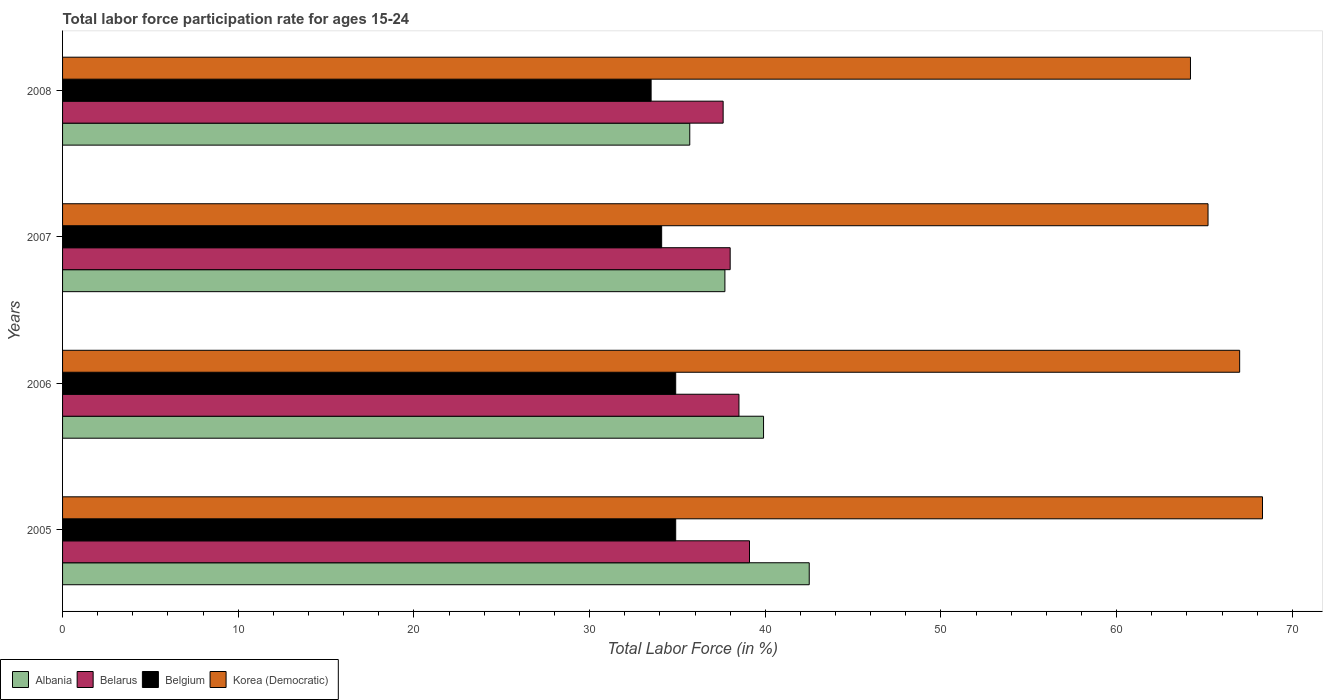How many different coloured bars are there?
Offer a very short reply. 4. Are the number of bars per tick equal to the number of legend labels?
Your answer should be compact. Yes. How many bars are there on the 2nd tick from the top?
Provide a succinct answer. 4. What is the label of the 2nd group of bars from the top?
Your answer should be very brief. 2007. What is the labor force participation rate in Belgium in 2007?
Your answer should be very brief. 34.1. Across all years, what is the maximum labor force participation rate in Albania?
Offer a terse response. 42.5. Across all years, what is the minimum labor force participation rate in Belarus?
Provide a succinct answer. 37.6. What is the total labor force participation rate in Korea (Democratic) in the graph?
Provide a succinct answer. 264.7. What is the difference between the labor force participation rate in Korea (Democratic) in 2006 and that in 2008?
Your answer should be compact. 2.8. What is the difference between the labor force participation rate in Belarus in 2006 and the labor force participation rate in Belgium in 2007?
Offer a terse response. 4.4. What is the average labor force participation rate in Korea (Democratic) per year?
Your answer should be compact. 66.17. In the year 2005, what is the difference between the labor force participation rate in Korea (Democratic) and labor force participation rate in Albania?
Keep it short and to the point. 25.8. In how many years, is the labor force participation rate in Korea (Democratic) greater than 56 %?
Your answer should be very brief. 4. What is the ratio of the labor force participation rate in Albania in 2007 to that in 2008?
Give a very brief answer. 1.06. Is the labor force participation rate in Korea (Democratic) in 2005 less than that in 2008?
Provide a succinct answer. No. Is the difference between the labor force participation rate in Korea (Democratic) in 2006 and 2008 greater than the difference between the labor force participation rate in Albania in 2006 and 2008?
Give a very brief answer. No. What is the difference between the highest and the second highest labor force participation rate in Korea (Democratic)?
Keep it short and to the point. 1.3. What is the difference between the highest and the lowest labor force participation rate in Albania?
Provide a short and direct response. 6.8. What does the 3rd bar from the top in 2006 represents?
Provide a short and direct response. Belarus. What does the 1st bar from the bottom in 2005 represents?
Your answer should be compact. Albania. How many bars are there?
Make the answer very short. 16. Are all the bars in the graph horizontal?
Your response must be concise. Yes. Are the values on the major ticks of X-axis written in scientific E-notation?
Offer a terse response. No. Does the graph contain grids?
Provide a succinct answer. No. Where does the legend appear in the graph?
Provide a succinct answer. Bottom left. How are the legend labels stacked?
Offer a very short reply. Horizontal. What is the title of the graph?
Provide a succinct answer. Total labor force participation rate for ages 15-24. What is the label or title of the X-axis?
Offer a terse response. Total Labor Force (in %). What is the label or title of the Y-axis?
Make the answer very short. Years. What is the Total Labor Force (in %) of Albania in 2005?
Your answer should be compact. 42.5. What is the Total Labor Force (in %) in Belarus in 2005?
Provide a short and direct response. 39.1. What is the Total Labor Force (in %) in Belgium in 2005?
Offer a very short reply. 34.9. What is the Total Labor Force (in %) of Korea (Democratic) in 2005?
Your response must be concise. 68.3. What is the Total Labor Force (in %) in Albania in 2006?
Ensure brevity in your answer.  39.9. What is the Total Labor Force (in %) in Belarus in 2006?
Your response must be concise. 38.5. What is the Total Labor Force (in %) of Belgium in 2006?
Give a very brief answer. 34.9. What is the Total Labor Force (in %) of Albania in 2007?
Make the answer very short. 37.7. What is the Total Labor Force (in %) in Belgium in 2007?
Give a very brief answer. 34.1. What is the Total Labor Force (in %) of Korea (Democratic) in 2007?
Offer a terse response. 65.2. What is the Total Labor Force (in %) in Albania in 2008?
Your response must be concise. 35.7. What is the Total Labor Force (in %) of Belarus in 2008?
Make the answer very short. 37.6. What is the Total Labor Force (in %) in Belgium in 2008?
Ensure brevity in your answer.  33.5. What is the Total Labor Force (in %) of Korea (Democratic) in 2008?
Provide a succinct answer. 64.2. Across all years, what is the maximum Total Labor Force (in %) of Albania?
Your answer should be very brief. 42.5. Across all years, what is the maximum Total Labor Force (in %) in Belarus?
Your response must be concise. 39.1. Across all years, what is the maximum Total Labor Force (in %) in Belgium?
Give a very brief answer. 34.9. Across all years, what is the maximum Total Labor Force (in %) of Korea (Democratic)?
Your answer should be very brief. 68.3. Across all years, what is the minimum Total Labor Force (in %) of Albania?
Offer a terse response. 35.7. Across all years, what is the minimum Total Labor Force (in %) of Belarus?
Your response must be concise. 37.6. Across all years, what is the minimum Total Labor Force (in %) of Belgium?
Give a very brief answer. 33.5. Across all years, what is the minimum Total Labor Force (in %) of Korea (Democratic)?
Ensure brevity in your answer.  64.2. What is the total Total Labor Force (in %) in Albania in the graph?
Your response must be concise. 155.8. What is the total Total Labor Force (in %) in Belarus in the graph?
Provide a short and direct response. 153.2. What is the total Total Labor Force (in %) of Belgium in the graph?
Your answer should be very brief. 137.4. What is the total Total Labor Force (in %) of Korea (Democratic) in the graph?
Make the answer very short. 264.7. What is the difference between the Total Labor Force (in %) in Albania in 2005 and that in 2006?
Provide a short and direct response. 2.6. What is the difference between the Total Labor Force (in %) of Belarus in 2005 and that in 2006?
Keep it short and to the point. 0.6. What is the difference between the Total Labor Force (in %) of Belgium in 2005 and that in 2006?
Provide a succinct answer. 0. What is the difference between the Total Labor Force (in %) of Korea (Democratic) in 2005 and that in 2006?
Keep it short and to the point. 1.3. What is the difference between the Total Labor Force (in %) in Albania in 2005 and that in 2007?
Make the answer very short. 4.8. What is the difference between the Total Labor Force (in %) of Belgium in 2005 and that in 2007?
Ensure brevity in your answer.  0.8. What is the difference between the Total Labor Force (in %) in Korea (Democratic) in 2005 and that in 2007?
Keep it short and to the point. 3.1. What is the difference between the Total Labor Force (in %) in Albania in 2005 and that in 2008?
Make the answer very short. 6.8. What is the difference between the Total Labor Force (in %) in Belgium in 2005 and that in 2008?
Offer a terse response. 1.4. What is the difference between the Total Labor Force (in %) in Albania in 2006 and that in 2007?
Keep it short and to the point. 2.2. What is the difference between the Total Labor Force (in %) in Belarus in 2006 and that in 2007?
Provide a succinct answer. 0.5. What is the difference between the Total Labor Force (in %) in Albania in 2006 and that in 2008?
Keep it short and to the point. 4.2. What is the difference between the Total Labor Force (in %) of Belarus in 2006 and that in 2008?
Make the answer very short. 0.9. What is the difference between the Total Labor Force (in %) in Belgium in 2006 and that in 2008?
Make the answer very short. 1.4. What is the difference between the Total Labor Force (in %) of Korea (Democratic) in 2006 and that in 2008?
Offer a very short reply. 2.8. What is the difference between the Total Labor Force (in %) of Albania in 2007 and that in 2008?
Offer a very short reply. 2. What is the difference between the Total Labor Force (in %) of Belarus in 2007 and that in 2008?
Make the answer very short. 0.4. What is the difference between the Total Labor Force (in %) in Albania in 2005 and the Total Labor Force (in %) in Korea (Democratic) in 2006?
Keep it short and to the point. -24.5. What is the difference between the Total Labor Force (in %) in Belarus in 2005 and the Total Labor Force (in %) in Belgium in 2006?
Your answer should be very brief. 4.2. What is the difference between the Total Labor Force (in %) in Belarus in 2005 and the Total Labor Force (in %) in Korea (Democratic) in 2006?
Offer a very short reply. -27.9. What is the difference between the Total Labor Force (in %) of Belgium in 2005 and the Total Labor Force (in %) of Korea (Democratic) in 2006?
Your answer should be very brief. -32.1. What is the difference between the Total Labor Force (in %) in Albania in 2005 and the Total Labor Force (in %) in Belarus in 2007?
Your answer should be very brief. 4.5. What is the difference between the Total Labor Force (in %) of Albania in 2005 and the Total Labor Force (in %) of Belgium in 2007?
Give a very brief answer. 8.4. What is the difference between the Total Labor Force (in %) in Albania in 2005 and the Total Labor Force (in %) in Korea (Democratic) in 2007?
Provide a short and direct response. -22.7. What is the difference between the Total Labor Force (in %) in Belarus in 2005 and the Total Labor Force (in %) in Korea (Democratic) in 2007?
Provide a succinct answer. -26.1. What is the difference between the Total Labor Force (in %) in Belgium in 2005 and the Total Labor Force (in %) in Korea (Democratic) in 2007?
Your answer should be compact. -30.3. What is the difference between the Total Labor Force (in %) of Albania in 2005 and the Total Labor Force (in %) of Korea (Democratic) in 2008?
Your answer should be compact. -21.7. What is the difference between the Total Labor Force (in %) in Belarus in 2005 and the Total Labor Force (in %) in Belgium in 2008?
Your response must be concise. 5.6. What is the difference between the Total Labor Force (in %) in Belarus in 2005 and the Total Labor Force (in %) in Korea (Democratic) in 2008?
Your answer should be compact. -25.1. What is the difference between the Total Labor Force (in %) in Belgium in 2005 and the Total Labor Force (in %) in Korea (Democratic) in 2008?
Keep it short and to the point. -29.3. What is the difference between the Total Labor Force (in %) in Albania in 2006 and the Total Labor Force (in %) in Korea (Democratic) in 2007?
Offer a very short reply. -25.3. What is the difference between the Total Labor Force (in %) of Belarus in 2006 and the Total Labor Force (in %) of Belgium in 2007?
Provide a succinct answer. 4.4. What is the difference between the Total Labor Force (in %) in Belarus in 2006 and the Total Labor Force (in %) in Korea (Democratic) in 2007?
Your answer should be very brief. -26.7. What is the difference between the Total Labor Force (in %) of Belgium in 2006 and the Total Labor Force (in %) of Korea (Democratic) in 2007?
Keep it short and to the point. -30.3. What is the difference between the Total Labor Force (in %) in Albania in 2006 and the Total Labor Force (in %) in Korea (Democratic) in 2008?
Provide a short and direct response. -24.3. What is the difference between the Total Labor Force (in %) of Belarus in 2006 and the Total Labor Force (in %) of Belgium in 2008?
Offer a very short reply. 5. What is the difference between the Total Labor Force (in %) in Belarus in 2006 and the Total Labor Force (in %) in Korea (Democratic) in 2008?
Provide a succinct answer. -25.7. What is the difference between the Total Labor Force (in %) in Belgium in 2006 and the Total Labor Force (in %) in Korea (Democratic) in 2008?
Make the answer very short. -29.3. What is the difference between the Total Labor Force (in %) of Albania in 2007 and the Total Labor Force (in %) of Belarus in 2008?
Your answer should be very brief. 0.1. What is the difference between the Total Labor Force (in %) in Albania in 2007 and the Total Labor Force (in %) in Belgium in 2008?
Give a very brief answer. 4.2. What is the difference between the Total Labor Force (in %) of Albania in 2007 and the Total Labor Force (in %) of Korea (Democratic) in 2008?
Make the answer very short. -26.5. What is the difference between the Total Labor Force (in %) of Belarus in 2007 and the Total Labor Force (in %) of Belgium in 2008?
Provide a succinct answer. 4.5. What is the difference between the Total Labor Force (in %) in Belarus in 2007 and the Total Labor Force (in %) in Korea (Democratic) in 2008?
Offer a very short reply. -26.2. What is the difference between the Total Labor Force (in %) in Belgium in 2007 and the Total Labor Force (in %) in Korea (Democratic) in 2008?
Provide a succinct answer. -30.1. What is the average Total Labor Force (in %) of Albania per year?
Your answer should be compact. 38.95. What is the average Total Labor Force (in %) of Belarus per year?
Ensure brevity in your answer.  38.3. What is the average Total Labor Force (in %) of Belgium per year?
Your answer should be compact. 34.35. What is the average Total Labor Force (in %) of Korea (Democratic) per year?
Your answer should be compact. 66.17. In the year 2005, what is the difference between the Total Labor Force (in %) of Albania and Total Labor Force (in %) of Belarus?
Make the answer very short. 3.4. In the year 2005, what is the difference between the Total Labor Force (in %) in Albania and Total Labor Force (in %) in Belgium?
Your answer should be very brief. 7.6. In the year 2005, what is the difference between the Total Labor Force (in %) of Albania and Total Labor Force (in %) of Korea (Democratic)?
Offer a terse response. -25.8. In the year 2005, what is the difference between the Total Labor Force (in %) in Belarus and Total Labor Force (in %) in Belgium?
Offer a terse response. 4.2. In the year 2005, what is the difference between the Total Labor Force (in %) of Belarus and Total Labor Force (in %) of Korea (Democratic)?
Offer a terse response. -29.2. In the year 2005, what is the difference between the Total Labor Force (in %) of Belgium and Total Labor Force (in %) of Korea (Democratic)?
Offer a very short reply. -33.4. In the year 2006, what is the difference between the Total Labor Force (in %) in Albania and Total Labor Force (in %) in Belgium?
Make the answer very short. 5. In the year 2006, what is the difference between the Total Labor Force (in %) of Albania and Total Labor Force (in %) of Korea (Democratic)?
Provide a short and direct response. -27.1. In the year 2006, what is the difference between the Total Labor Force (in %) of Belarus and Total Labor Force (in %) of Korea (Democratic)?
Your answer should be compact. -28.5. In the year 2006, what is the difference between the Total Labor Force (in %) of Belgium and Total Labor Force (in %) of Korea (Democratic)?
Keep it short and to the point. -32.1. In the year 2007, what is the difference between the Total Labor Force (in %) in Albania and Total Labor Force (in %) in Belarus?
Provide a short and direct response. -0.3. In the year 2007, what is the difference between the Total Labor Force (in %) in Albania and Total Labor Force (in %) in Korea (Democratic)?
Offer a very short reply. -27.5. In the year 2007, what is the difference between the Total Labor Force (in %) in Belarus and Total Labor Force (in %) in Belgium?
Provide a succinct answer. 3.9. In the year 2007, what is the difference between the Total Labor Force (in %) in Belarus and Total Labor Force (in %) in Korea (Democratic)?
Your answer should be compact. -27.2. In the year 2007, what is the difference between the Total Labor Force (in %) in Belgium and Total Labor Force (in %) in Korea (Democratic)?
Your response must be concise. -31.1. In the year 2008, what is the difference between the Total Labor Force (in %) in Albania and Total Labor Force (in %) in Belarus?
Ensure brevity in your answer.  -1.9. In the year 2008, what is the difference between the Total Labor Force (in %) of Albania and Total Labor Force (in %) of Belgium?
Your answer should be very brief. 2.2. In the year 2008, what is the difference between the Total Labor Force (in %) in Albania and Total Labor Force (in %) in Korea (Democratic)?
Provide a succinct answer. -28.5. In the year 2008, what is the difference between the Total Labor Force (in %) in Belarus and Total Labor Force (in %) in Belgium?
Provide a short and direct response. 4.1. In the year 2008, what is the difference between the Total Labor Force (in %) of Belarus and Total Labor Force (in %) of Korea (Democratic)?
Ensure brevity in your answer.  -26.6. In the year 2008, what is the difference between the Total Labor Force (in %) in Belgium and Total Labor Force (in %) in Korea (Democratic)?
Offer a very short reply. -30.7. What is the ratio of the Total Labor Force (in %) in Albania in 2005 to that in 2006?
Provide a short and direct response. 1.07. What is the ratio of the Total Labor Force (in %) of Belarus in 2005 to that in 2006?
Keep it short and to the point. 1.02. What is the ratio of the Total Labor Force (in %) in Korea (Democratic) in 2005 to that in 2006?
Your answer should be compact. 1.02. What is the ratio of the Total Labor Force (in %) of Albania in 2005 to that in 2007?
Offer a terse response. 1.13. What is the ratio of the Total Labor Force (in %) of Belarus in 2005 to that in 2007?
Your answer should be very brief. 1.03. What is the ratio of the Total Labor Force (in %) of Belgium in 2005 to that in 2007?
Give a very brief answer. 1.02. What is the ratio of the Total Labor Force (in %) in Korea (Democratic) in 2005 to that in 2007?
Your answer should be very brief. 1.05. What is the ratio of the Total Labor Force (in %) of Albania in 2005 to that in 2008?
Offer a very short reply. 1.19. What is the ratio of the Total Labor Force (in %) of Belarus in 2005 to that in 2008?
Your answer should be compact. 1.04. What is the ratio of the Total Labor Force (in %) in Belgium in 2005 to that in 2008?
Give a very brief answer. 1.04. What is the ratio of the Total Labor Force (in %) in Korea (Democratic) in 2005 to that in 2008?
Offer a terse response. 1.06. What is the ratio of the Total Labor Force (in %) of Albania in 2006 to that in 2007?
Your answer should be compact. 1.06. What is the ratio of the Total Labor Force (in %) in Belarus in 2006 to that in 2007?
Keep it short and to the point. 1.01. What is the ratio of the Total Labor Force (in %) of Belgium in 2006 to that in 2007?
Offer a terse response. 1.02. What is the ratio of the Total Labor Force (in %) of Korea (Democratic) in 2006 to that in 2007?
Make the answer very short. 1.03. What is the ratio of the Total Labor Force (in %) of Albania in 2006 to that in 2008?
Give a very brief answer. 1.12. What is the ratio of the Total Labor Force (in %) of Belarus in 2006 to that in 2008?
Make the answer very short. 1.02. What is the ratio of the Total Labor Force (in %) in Belgium in 2006 to that in 2008?
Offer a very short reply. 1.04. What is the ratio of the Total Labor Force (in %) in Korea (Democratic) in 2006 to that in 2008?
Keep it short and to the point. 1.04. What is the ratio of the Total Labor Force (in %) in Albania in 2007 to that in 2008?
Ensure brevity in your answer.  1.06. What is the ratio of the Total Labor Force (in %) of Belarus in 2007 to that in 2008?
Provide a succinct answer. 1.01. What is the ratio of the Total Labor Force (in %) in Belgium in 2007 to that in 2008?
Make the answer very short. 1.02. What is the ratio of the Total Labor Force (in %) of Korea (Democratic) in 2007 to that in 2008?
Ensure brevity in your answer.  1.02. What is the difference between the highest and the second highest Total Labor Force (in %) in Belarus?
Make the answer very short. 0.6. What is the difference between the highest and the second highest Total Labor Force (in %) in Korea (Democratic)?
Offer a very short reply. 1.3. What is the difference between the highest and the lowest Total Labor Force (in %) in Albania?
Provide a short and direct response. 6.8. What is the difference between the highest and the lowest Total Labor Force (in %) in Belgium?
Provide a short and direct response. 1.4. 